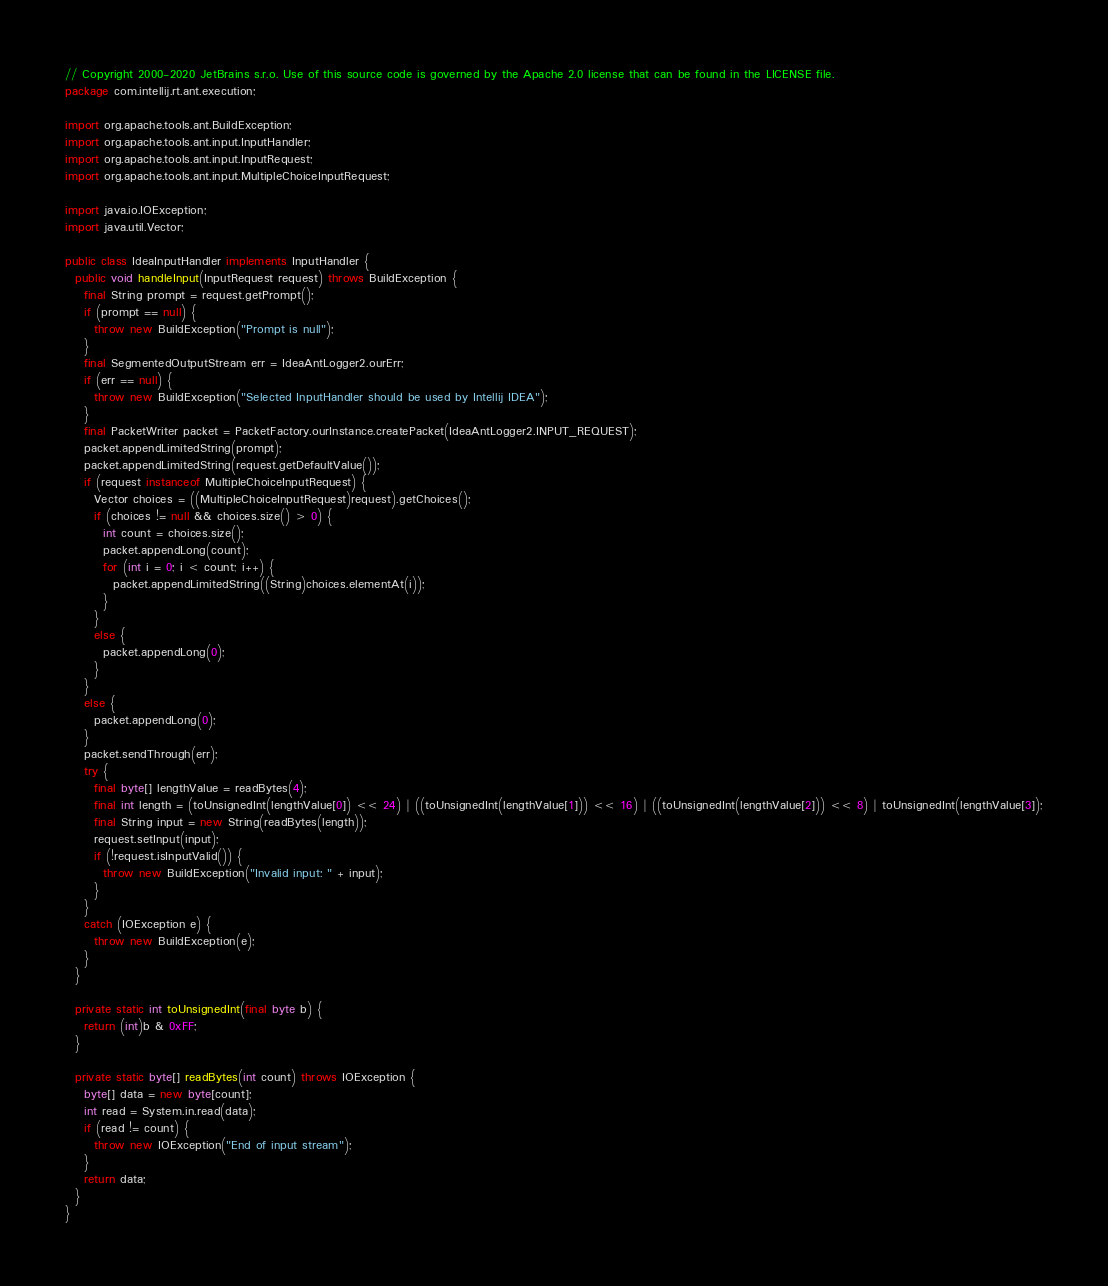Convert code to text. <code><loc_0><loc_0><loc_500><loc_500><_Java_>// Copyright 2000-2020 JetBrains s.r.o. Use of this source code is governed by the Apache 2.0 license that can be found in the LICENSE file.
package com.intellij.rt.ant.execution;

import org.apache.tools.ant.BuildException;
import org.apache.tools.ant.input.InputHandler;
import org.apache.tools.ant.input.InputRequest;
import org.apache.tools.ant.input.MultipleChoiceInputRequest;

import java.io.IOException;
import java.util.Vector;

public class IdeaInputHandler implements InputHandler {
  public void handleInput(InputRequest request) throws BuildException {
    final String prompt = request.getPrompt();
    if (prompt == null) {
      throw new BuildException("Prompt is null");
    }
    final SegmentedOutputStream err = IdeaAntLogger2.ourErr;
    if (err == null) {
      throw new BuildException("Selected InputHandler should be used by Intellij IDEA");
    }
    final PacketWriter packet = PacketFactory.ourInstance.createPacket(IdeaAntLogger2.INPUT_REQUEST);
    packet.appendLimitedString(prompt);
    packet.appendLimitedString(request.getDefaultValue());
    if (request instanceof MultipleChoiceInputRequest) {
      Vector choices = ((MultipleChoiceInputRequest)request).getChoices();
      if (choices != null && choices.size() > 0) {
        int count = choices.size();
        packet.appendLong(count);
        for (int i = 0; i < count; i++) {
          packet.appendLimitedString((String)choices.elementAt(i));
        }
      }
      else {
        packet.appendLong(0);
      }
    }
    else {
      packet.appendLong(0);
    }
    packet.sendThrough(err);
    try {
      final byte[] lengthValue = readBytes(4);
      final int length = (toUnsignedInt(lengthValue[0]) << 24) | ((toUnsignedInt(lengthValue[1])) << 16) | ((toUnsignedInt(lengthValue[2])) << 8) | toUnsignedInt(lengthValue[3]);
      final String input = new String(readBytes(length));
      request.setInput(input);
      if (!request.isInputValid()) {
        throw new BuildException("Invalid input: " + input);
      }
    }
    catch (IOException e) {
      throw new BuildException(e);
    }
  }

  private static int toUnsignedInt(final byte b) {
    return (int)b & 0xFF;
  }

  private static byte[] readBytes(int count) throws IOException {
    byte[] data = new byte[count];
    int read = System.in.read(data);
    if (read != count) {
      throw new IOException("End of input stream");
    }
    return data;
  }
}
</code> 